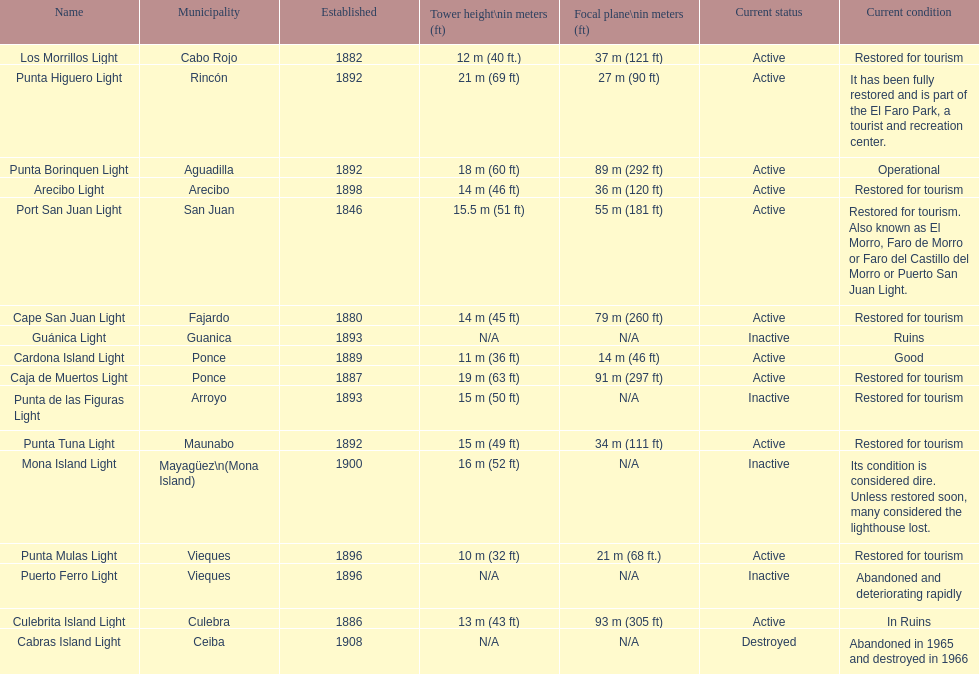How many establishments are restored for tourism? 9. 